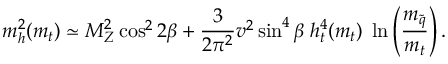Convert formula to latex. <formula><loc_0><loc_0><loc_500><loc_500>m _ { h } ^ { 2 } ( m _ { t } ) \simeq M _ { Z } ^ { 2 } \cos ^ { 2 } 2 \beta + \frac { 3 } { 2 \pi ^ { 2 } } v ^ { 2 } \sin ^ { 4 } \beta \, h _ { t } ^ { 4 } ( m _ { t } ) \, \ln \left ( \frac { m _ { \tilde { q } } } { m _ { t } } \right ) .</formula> 